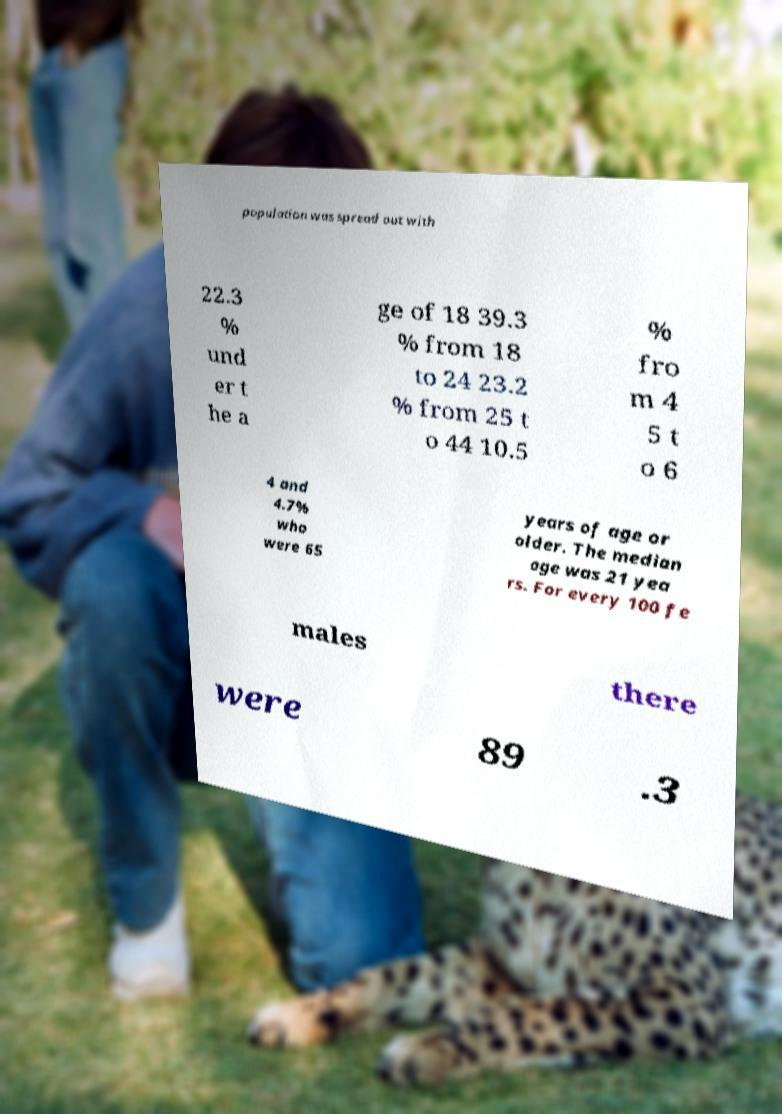Can you read and provide the text displayed in the image?This photo seems to have some interesting text. Can you extract and type it out for me? population was spread out with 22.3 % und er t he a ge of 18 39.3 % from 18 to 24 23.2 % from 25 t o 44 10.5 % fro m 4 5 t o 6 4 and 4.7% who were 65 years of age or older. The median age was 21 yea rs. For every 100 fe males there were 89 .3 